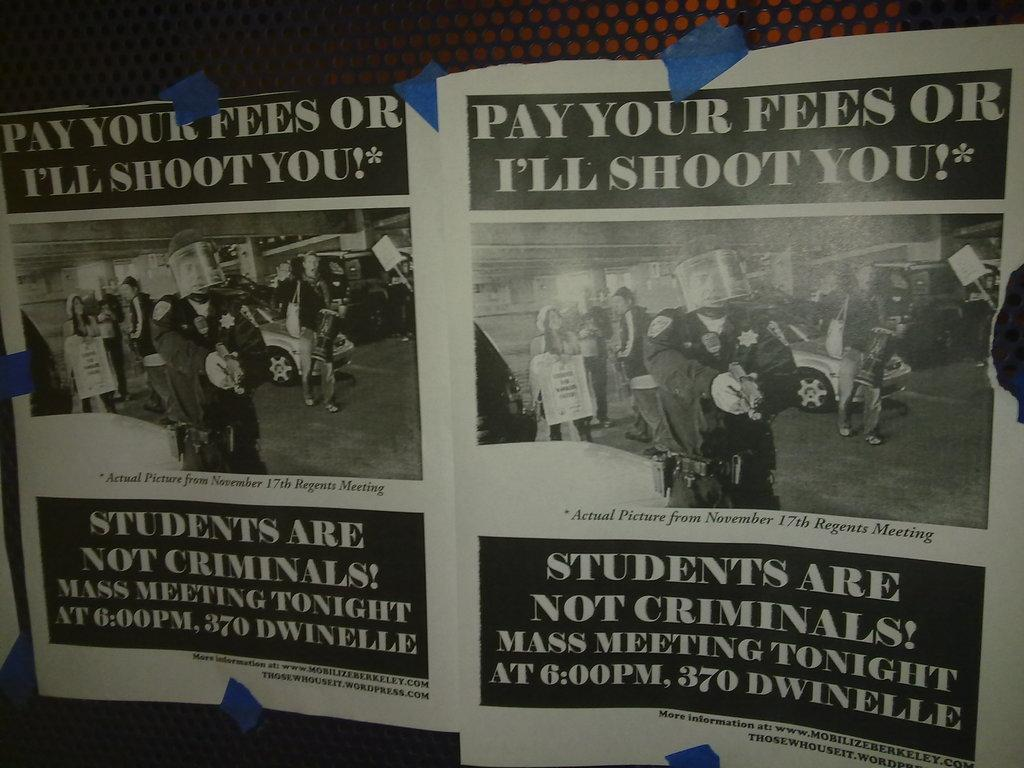<image>
Give a short and clear explanation of the subsequent image. A flyer for a student meeting taking place at 6:00PM at 370 Dwindelle. 